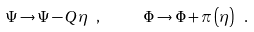<formula> <loc_0><loc_0><loc_500><loc_500>\Psi \rightarrow \Psi - Q \eta \ , \quad \ \Phi \rightarrow \Phi + \pi \left ( \eta \right ) \ .</formula> 